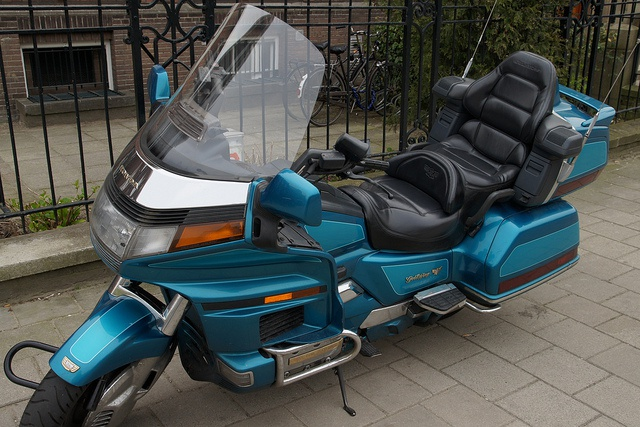Describe the objects in this image and their specific colors. I can see motorcycle in black, gray, blue, and darkgray tones, bicycle in black and gray tones, and bicycle in black, gray, and darkgray tones in this image. 